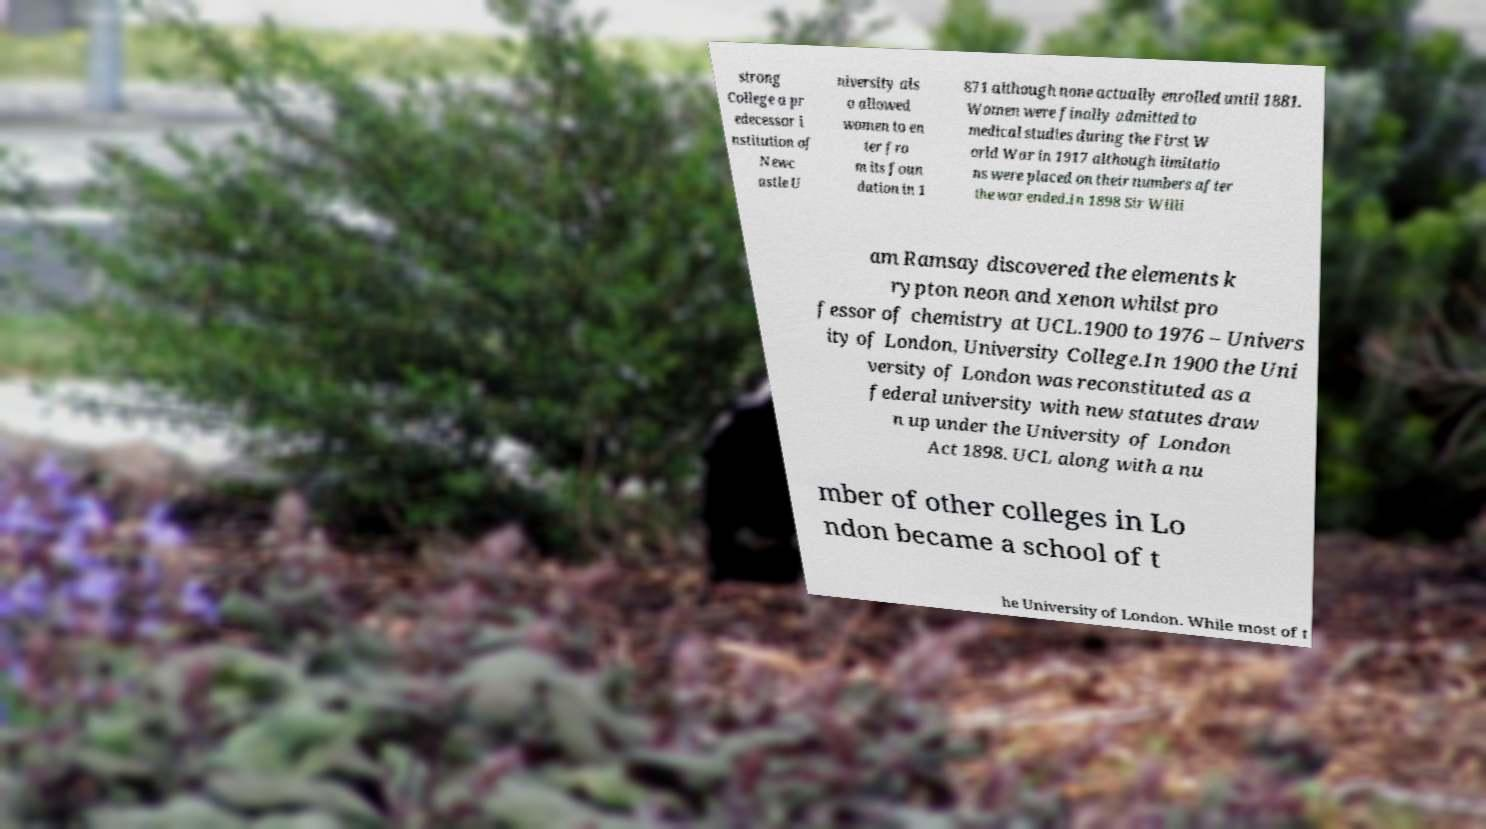What messages or text are displayed in this image? I need them in a readable, typed format. strong College a pr edecessor i nstitution of Newc astle U niversity als o allowed women to en ter fro m its foun dation in 1 871 although none actually enrolled until 1881. Women were finally admitted to medical studies during the First W orld War in 1917 although limitatio ns were placed on their numbers after the war ended.In 1898 Sir Willi am Ramsay discovered the elements k rypton neon and xenon whilst pro fessor of chemistry at UCL.1900 to 1976 – Univers ity of London, University College.In 1900 the Uni versity of London was reconstituted as a federal university with new statutes draw n up under the University of London Act 1898. UCL along with a nu mber of other colleges in Lo ndon became a school of t he University of London. While most of t 